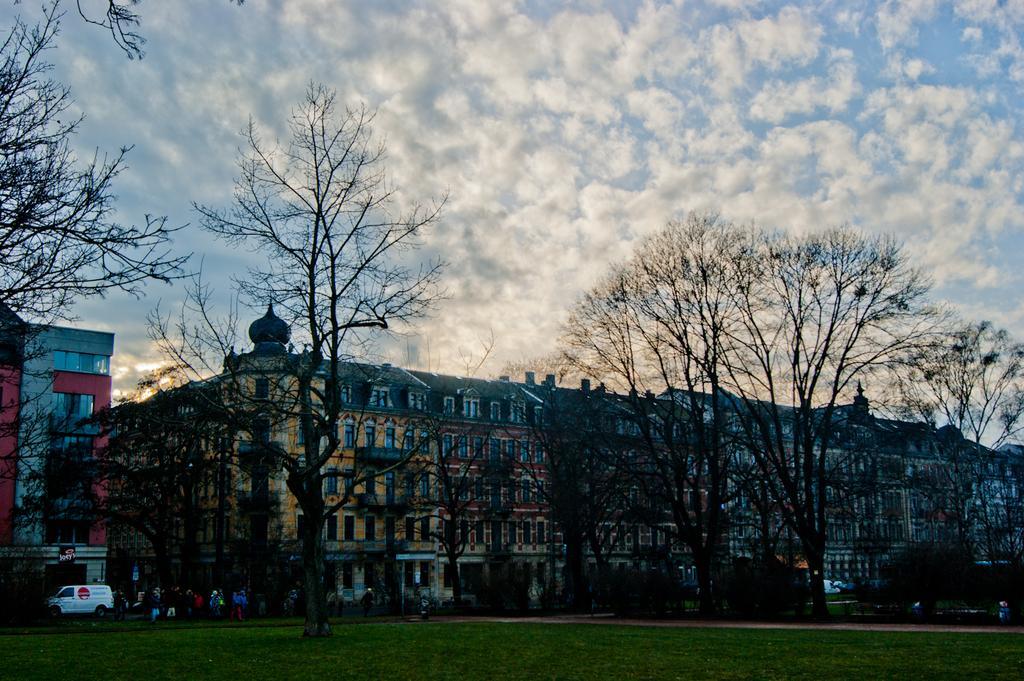Can you describe this image briefly? In this image we can see grass, vehicle, boards, people, trees, and buildings. In the background there is sky with clouds. 